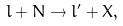<formula> <loc_0><loc_0><loc_500><loc_500>l + N \to l ^ { \prime } + X ,</formula> 